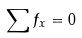<formula> <loc_0><loc_0><loc_500><loc_500>\sum f _ { x } = 0</formula> 